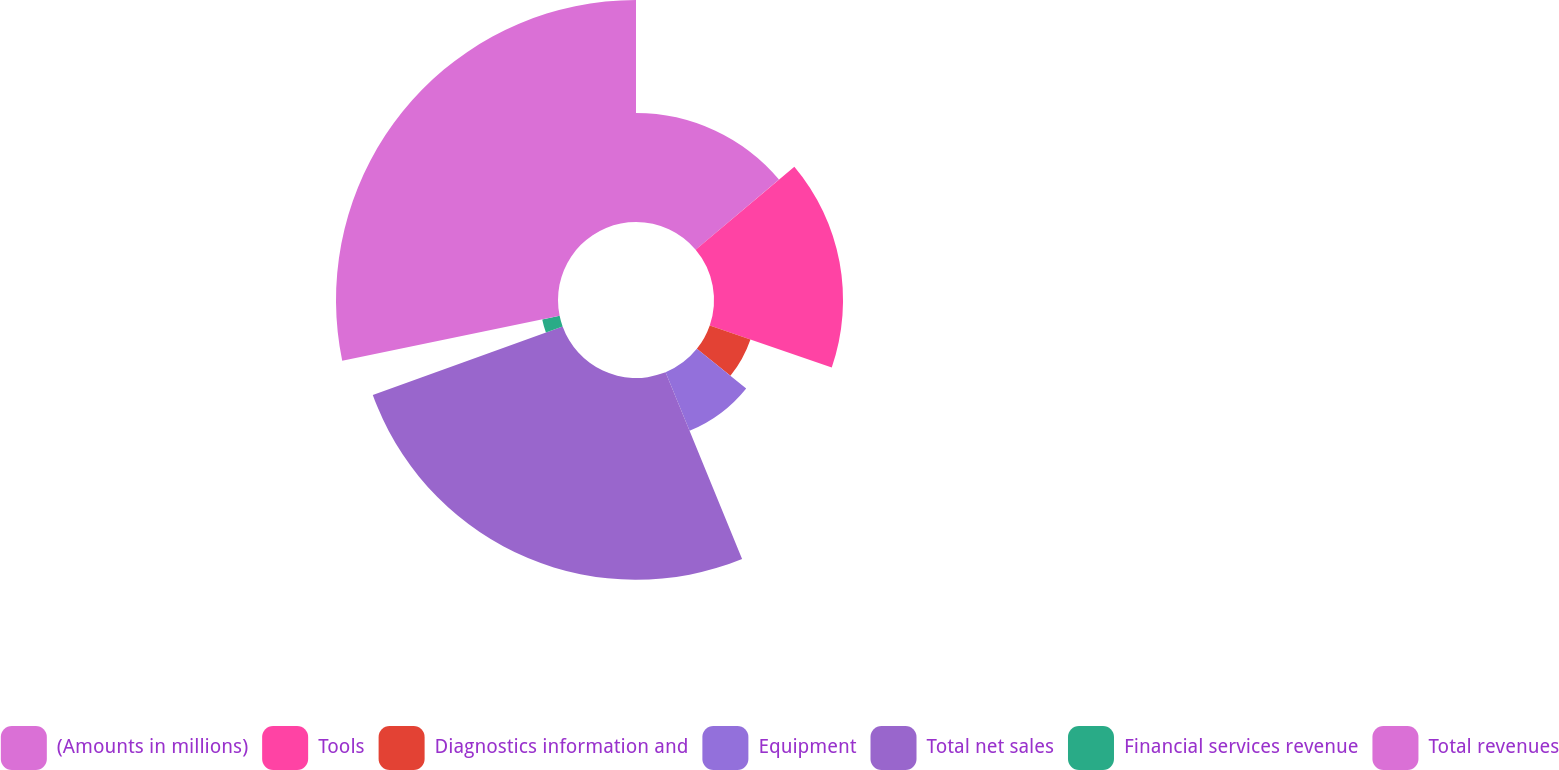Convert chart. <chart><loc_0><loc_0><loc_500><loc_500><pie_chart><fcel>(Amounts in millions)<fcel>Tools<fcel>Diagnostics information and<fcel>Equipment<fcel>Total net sales<fcel>Financial services revenue<fcel>Total revenues<nl><fcel>13.86%<fcel>16.42%<fcel>5.48%<fcel>8.05%<fcel>25.68%<fcel>2.26%<fcel>28.25%<nl></chart> 